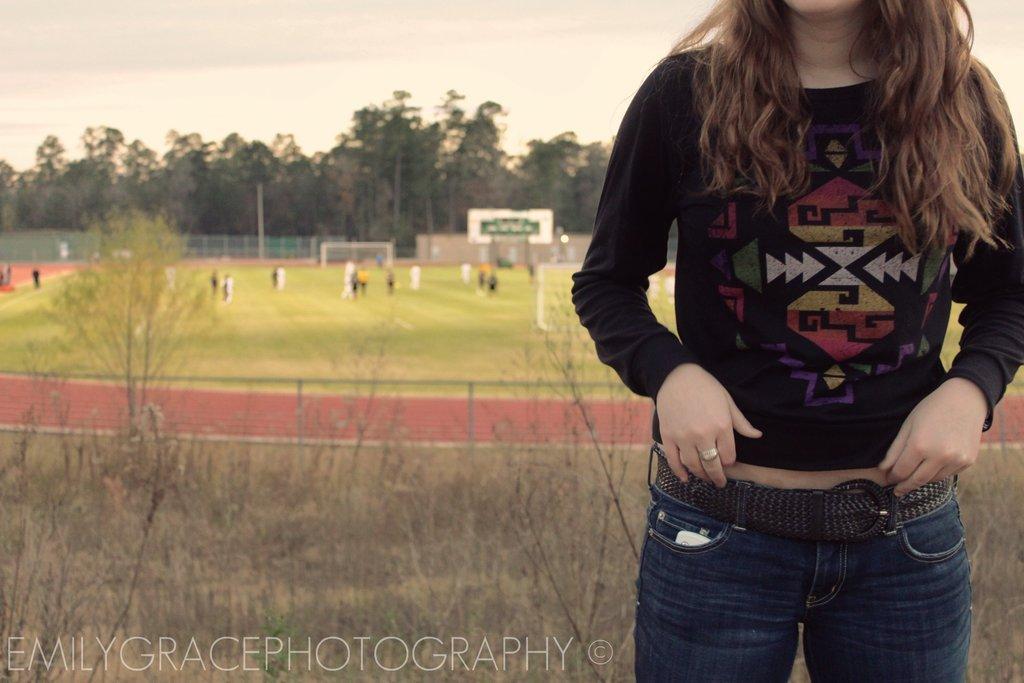How would you summarize this image in a sentence or two? In this image we can see a woman standing on the ground. In the background we can see sports ground, persons standing on the ground, trees, fence and sky with clouds. 